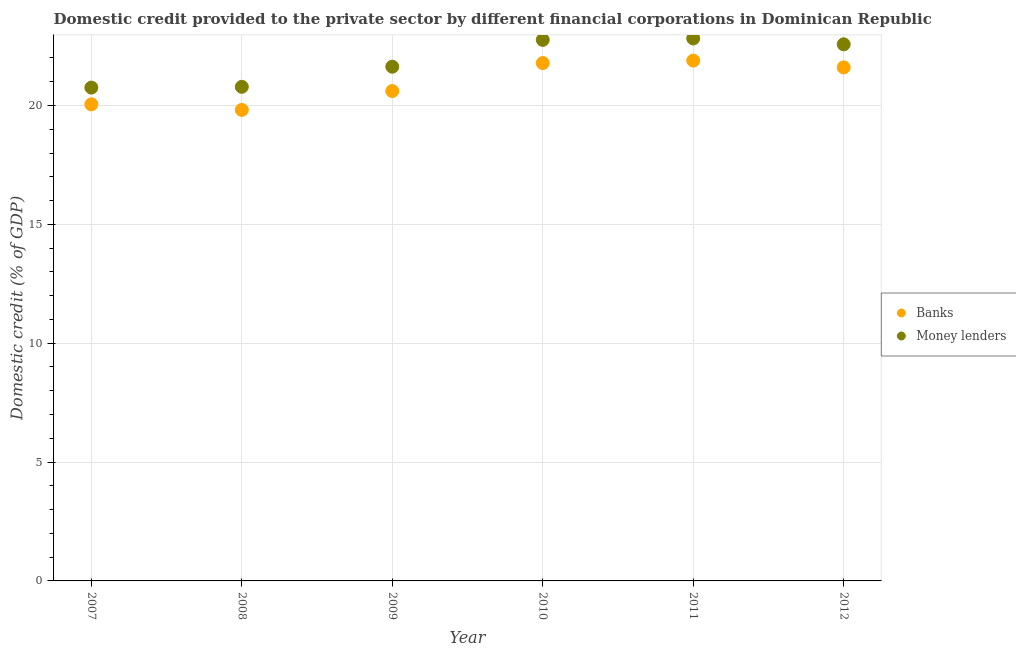What is the domestic credit provided by banks in 2008?
Offer a very short reply. 19.81. Across all years, what is the maximum domestic credit provided by banks?
Provide a succinct answer. 21.89. Across all years, what is the minimum domestic credit provided by money lenders?
Give a very brief answer. 20.75. In which year was the domestic credit provided by money lenders minimum?
Keep it short and to the point. 2007. What is the total domestic credit provided by banks in the graph?
Give a very brief answer. 125.74. What is the difference between the domestic credit provided by banks in 2008 and that in 2009?
Your answer should be compact. -0.79. What is the difference between the domestic credit provided by banks in 2011 and the domestic credit provided by money lenders in 2012?
Your answer should be very brief. -0.69. What is the average domestic credit provided by banks per year?
Your response must be concise. 20.96. In the year 2008, what is the difference between the domestic credit provided by banks and domestic credit provided by money lenders?
Your answer should be compact. -0.97. In how many years, is the domestic credit provided by money lenders greater than 17 %?
Ensure brevity in your answer.  6. What is the ratio of the domestic credit provided by banks in 2007 to that in 2010?
Ensure brevity in your answer.  0.92. Is the difference between the domestic credit provided by banks in 2008 and 2010 greater than the difference between the domestic credit provided by money lenders in 2008 and 2010?
Offer a very short reply. Yes. What is the difference between the highest and the second highest domestic credit provided by banks?
Ensure brevity in your answer.  0.1. What is the difference between the highest and the lowest domestic credit provided by banks?
Offer a very short reply. 2.07. Is the domestic credit provided by banks strictly greater than the domestic credit provided by money lenders over the years?
Offer a very short reply. No. How many dotlines are there?
Your answer should be very brief. 2. How many years are there in the graph?
Ensure brevity in your answer.  6. Does the graph contain any zero values?
Your answer should be very brief. No. How many legend labels are there?
Provide a short and direct response. 2. How are the legend labels stacked?
Your answer should be very brief. Vertical. What is the title of the graph?
Your answer should be compact. Domestic credit provided to the private sector by different financial corporations in Dominican Republic. What is the label or title of the X-axis?
Ensure brevity in your answer.  Year. What is the label or title of the Y-axis?
Your response must be concise. Domestic credit (% of GDP). What is the Domestic credit (% of GDP) in Banks in 2007?
Ensure brevity in your answer.  20.05. What is the Domestic credit (% of GDP) in Money lenders in 2007?
Give a very brief answer. 20.75. What is the Domestic credit (% of GDP) of Banks in 2008?
Offer a terse response. 19.81. What is the Domestic credit (% of GDP) in Money lenders in 2008?
Your response must be concise. 20.79. What is the Domestic credit (% of GDP) of Banks in 2009?
Provide a succinct answer. 20.61. What is the Domestic credit (% of GDP) in Money lenders in 2009?
Your answer should be very brief. 21.63. What is the Domestic credit (% of GDP) of Banks in 2010?
Provide a short and direct response. 21.79. What is the Domestic credit (% of GDP) in Money lenders in 2010?
Ensure brevity in your answer.  22.76. What is the Domestic credit (% of GDP) of Banks in 2011?
Make the answer very short. 21.89. What is the Domestic credit (% of GDP) in Money lenders in 2011?
Provide a short and direct response. 22.82. What is the Domestic credit (% of GDP) in Banks in 2012?
Provide a succinct answer. 21.6. What is the Domestic credit (% of GDP) of Money lenders in 2012?
Offer a very short reply. 22.57. Across all years, what is the maximum Domestic credit (% of GDP) in Banks?
Keep it short and to the point. 21.89. Across all years, what is the maximum Domestic credit (% of GDP) of Money lenders?
Offer a terse response. 22.82. Across all years, what is the minimum Domestic credit (% of GDP) of Banks?
Keep it short and to the point. 19.81. Across all years, what is the minimum Domestic credit (% of GDP) in Money lenders?
Make the answer very short. 20.75. What is the total Domestic credit (% of GDP) of Banks in the graph?
Provide a short and direct response. 125.74. What is the total Domestic credit (% of GDP) in Money lenders in the graph?
Provide a succinct answer. 131.32. What is the difference between the Domestic credit (% of GDP) in Banks in 2007 and that in 2008?
Your response must be concise. 0.23. What is the difference between the Domestic credit (% of GDP) in Money lenders in 2007 and that in 2008?
Your response must be concise. -0.03. What is the difference between the Domestic credit (% of GDP) in Banks in 2007 and that in 2009?
Offer a terse response. -0.56. What is the difference between the Domestic credit (% of GDP) in Money lenders in 2007 and that in 2009?
Provide a short and direct response. -0.88. What is the difference between the Domestic credit (% of GDP) of Banks in 2007 and that in 2010?
Provide a short and direct response. -1.74. What is the difference between the Domestic credit (% of GDP) of Money lenders in 2007 and that in 2010?
Your answer should be very brief. -2.01. What is the difference between the Domestic credit (% of GDP) in Banks in 2007 and that in 2011?
Provide a succinct answer. -1.84. What is the difference between the Domestic credit (% of GDP) of Money lenders in 2007 and that in 2011?
Your answer should be compact. -2.07. What is the difference between the Domestic credit (% of GDP) in Banks in 2007 and that in 2012?
Offer a terse response. -1.55. What is the difference between the Domestic credit (% of GDP) in Money lenders in 2007 and that in 2012?
Offer a very short reply. -1.82. What is the difference between the Domestic credit (% of GDP) in Banks in 2008 and that in 2009?
Your answer should be compact. -0.79. What is the difference between the Domestic credit (% of GDP) in Money lenders in 2008 and that in 2009?
Keep it short and to the point. -0.85. What is the difference between the Domestic credit (% of GDP) in Banks in 2008 and that in 2010?
Offer a very short reply. -1.97. What is the difference between the Domestic credit (% of GDP) of Money lenders in 2008 and that in 2010?
Keep it short and to the point. -1.97. What is the difference between the Domestic credit (% of GDP) in Banks in 2008 and that in 2011?
Provide a short and direct response. -2.07. What is the difference between the Domestic credit (% of GDP) of Money lenders in 2008 and that in 2011?
Offer a very short reply. -2.04. What is the difference between the Domestic credit (% of GDP) of Banks in 2008 and that in 2012?
Your answer should be very brief. -1.79. What is the difference between the Domestic credit (% of GDP) in Money lenders in 2008 and that in 2012?
Ensure brevity in your answer.  -1.79. What is the difference between the Domestic credit (% of GDP) in Banks in 2009 and that in 2010?
Give a very brief answer. -1.18. What is the difference between the Domestic credit (% of GDP) in Money lenders in 2009 and that in 2010?
Make the answer very short. -1.13. What is the difference between the Domestic credit (% of GDP) in Banks in 2009 and that in 2011?
Provide a succinct answer. -1.28. What is the difference between the Domestic credit (% of GDP) of Money lenders in 2009 and that in 2011?
Your answer should be compact. -1.19. What is the difference between the Domestic credit (% of GDP) in Banks in 2009 and that in 2012?
Ensure brevity in your answer.  -1. What is the difference between the Domestic credit (% of GDP) of Money lenders in 2009 and that in 2012?
Give a very brief answer. -0.94. What is the difference between the Domestic credit (% of GDP) of Banks in 2010 and that in 2011?
Keep it short and to the point. -0.1. What is the difference between the Domestic credit (% of GDP) in Money lenders in 2010 and that in 2011?
Provide a short and direct response. -0.06. What is the difference between the Domestic credit (% of GDP) in Banks in 2010 and that in 2012?
Keep it short and to the point. 0.18. What is the difference between the Domestic credit (% of GDP) of Money lenders in 2010 and that in 2012?
Offer a terse response. 0.19. What is the difference between the Domestic credit (% of GDP) in Banks in 2011 and that in 2012?
Your answer should be very brief. 0.29. What is the difference between the Domestic credit (% of GDP) in Money lenders in 2011 and that in 2012?
Give a very brief answer. 0.25. What is the difference between the Domestic credit (% of GDP) in Banks in 2007 and the Domestic credit (% of GDP) in Money lenders in 2008?
Offer a terse response. -0.74. What is the difference between the Domestic credit (% of GDP) of Banks in 2007 and the Domestic credit (% of GDP) of Money lenders in 2009?
Ensure brevity in your answer.  -1.58. What is the difference between the Domestic credit (% of GDP) of Banks in 2007 and the Domestic credit (% of GDP) of Money lenders in 2010?
Your answer should be very brief. -2.71. What is the difference between the Domestic credit (% of GDP) of Banks in 2007 and the Domestic credit (% of GDP) of Money lenders in 2011?
Offer a very short reply. -2.77. What is the difference between the Domestic credit (% of GDP) of Banks in 2007 and the Domestic credit (% of GDP) of Money lenders in 2012?
Provide a short and direct response. -2.53. What is the difference between the Domestic credit (% of GDP) in Banks in 2008 and the Domestic credit (% of GDP) in Money lenders in 2009?
Your answer should be compact. -1.82. What is the difference between the Domestic credit (% of GDP) in Banks in 2008 and the Domestic credit (% of GDP) in Money lenders in 2010?
Give a very brief answer. -2.95. What is the difference between the Domestic credit (% of GDP) of Banks in 2008 and the Domestic credit (% of GDP) of Money lenders in 2011?
Your answer should be very brief. -3.01. What is the difference between the Domestic credit (% of GDP) of Banks in 2008 and the Domestic credit (% of GDP) of Money lenders in 2012?
Ensure brevity in your answer.  -2.76. What is the difference between the Domestic credit (% of GDP) in Banks in 2009 and the Domestic credit (% of GDP) in Money lenders in 2010?
Keep it short and to the point. -2.15. What is the difference between the Domestic credit (% of GDP) in Banks in 2009 and the Domestic credit (% of GDP) in Money lenders in 2011?
Your answer should be compact. -2.21. What is the difference between the Domestic credit (% of GDP) in Banks in 2009 and the Domestic credit (% of GDP) in Money lenders in 2012?
Your answer should be very brief. -1.97. What is the difference between the Domestic credit (% of GDP) of Banks in 2010 and the Domestic credit (% of GDP) of Money lenders in 2011?
Offer a very short reply. -1.04. What is the difference between the Domestic credit (% of GDP) of Banks in 2010 and the Domestic credit (% of GDP) of Money lenders in 2012?
Your answer should be very brief. -0.79. What is the difference between the Domestic credit (% of GDP) of Banks in 2011 and the Domestic credit (% of GDP) of Money lenders in 2012?
Provide a succinct answer. -0.69. What is the average Domestic credit (% of GDP) of Banks per year?
Your answer should be compact. 20.96. What is the average Domestic credit (% of GDP) of Money lenders per year?
Your response must be concise. 21.89. In the year 2007, what is the difference between the Domestic credit (% of GDP) in Banks and Domestic credit (% of GDP) in Money lenders?
Give a very brief answer. -0.7. In the year 2008, what is the difference between the Domestic credit (% of GDP) of Banks and Domestic credit (% of GDP) of Money lenders?
Give a very brief answer. -0.97. In the year 2009, what is the difference between the Domestic credit (% of GDP) of Banks and Domestic credit (% of GDP) of Money lenders?
Provide a short and direct response. -1.02. In the year 2010, what is the difference between the Domestic credit (% of GDP) of Banks and Domestic credit (% of GDP) of Money lenders?
Offer a very short reply. -0.97. In the year 2011, what is the difference between the Domestic credit (% of GDP) in Banks and Domestic credit (% of GDP) in Money lenders?
Offer a terse response. -0.93. In the year 2012, what is the difference between the Domestic credit (% of GDP) of Banks and Domestic credit (% of GDP) of Money lenders?
Your response must be concise. -0.97. What is the ratio of the Domestic credit (% of GDP) of Banks in 2007 to that in 2008?
Your answer should be compact. 1.01. What is the ratio of the Domestic credit (% of GDP) in Money lenders in 2007 to that in 2008?
Give a very brief answer. 1. What is the ratio of the Domestic credit (% of GDP) of Banks in 2007 to that in 2009?
Make the answer very short. 0.97. What is the ratio of the Domestic credit (% of GDP) of Money lenders in 2007 to that in 2009?
Provide a short and direct response. 0.96. What is the ratio of the Domestic credit (% of GDP) in Banks in 2007 to that in 2010?
Give a very brief answer. 0.92. What is the ratio of the Domestic credit (% of GDP) of Money lenders in 2007 to that in 2010?
Ensure brevity in your answer.  0.91. What is the ratio of the Domestic credit (% of GDP) in Banks in 2007 to that in 2011?
Ensure brevity in your answer.  0.92. What is the ratio of the Domestic credit (% of GDP) in Money lenders in 2007 to that in 2011?
Ensure brevity in your answer.  0.91. What is the ratio of the Domestic credit (% of GDP) in Banks in 2007 to that in 2012?
Offer a very short reply. 0.93. What is the ratio of the Domestic credit (% of GDP) of Money lenders in 2007 to that in 2012?
Your answer should be compact. 0.92. What is the ratio of the Domestic credit (% of GDP) of Banks in 2008 to that in 2009?
Make the answer very short. 0.96. What is the ratio of the Domestic credit (% of GDP) of Money lenders in 2008 to that in 2009?
Give a very brief answer. 0.96. What is the ratio of the Domestic credit (% of GDP) in Banks in 2008 to that in 2010?
Your answer should be very brief. 0.91. What is the ratio of the Domestic credit (% of GDP) in Money lenders in 2008 to that in 2010?
Your response must be concise. 0.91. What is the ratio of the Domestic credit (% of GDP) in Banks in 2008 to that in 2011?
Provide a short and direct response. 0.91. What is the ratio of the Domestic credit (% of GDP) of Money lenders in 2008 to that in 2011?
Keep it short and to the point. 0.91. What is the ratio of the Domestic credit (% of GDP) of Banks in 2008 to that in 2012?
Ensure brevity in your answer.  0.92. What is the ratio of the Domestic credit (% of GDP) in Money lenders in 2008 to that in 2012?
Keep it short and to the point. 0.92. What is the ratio of the Domestic credit (% of GDP) in Banks in 2009 to that in 2010?
Your answer should be compact. 0.95. What is the ratio of the Domestic credit (% of GDP) in Money lenders in 2009 to that in 2010?
Your answer should be compact. 0.95. What is the ratio of the Domestic credit (% of GDP) in Banks in 2009 to that in 2011?
Provide a succinct answer. 0.94. What is the ratio of the Domestic credit (% of GDP) of Money lenders in 2009 to that in 2011?
Offer a very short reply. 0.95. What is the ratio of the Domestic credit (% of GDP) of Banks in 2009 to that in 2012?
Provide a short and direct response. 0.95. What is the ratio of the Domestic credit (% of GDP) in Money lenders in 2009 to that in 2012?
Provide a succinct answer. 0.96. What is the ratio of the Domestic credit (% of GDP) of Banks in 2010 to that in 2012?
Your answer should be compact. 1.01. What is the ratio of the Domestic credit (% of GDP) of Money lenders in 2010 to that in 2012?
Provide a succinct answer. 1.01. What is the ratio of the Domestic credit (% of GDP) of Banks in 2011 to that in 2012?
Provide a succinct answer. 1.01. What is the ratio of the Domestic credit (% of GDP) of Money lenders in 2011 to that in 2012?
Ensure brevity in your answer.  1.01. What is the difference between the highest and the second highest Domestic credit (% of GDP) of Banks?
Ensure brevity in your answer.  0.1. What is the difference between the highest and the second highest Domestic credit (% of GDP) of Money lenders?
Provide a short and direct response. 0.06. What is the difference between the highest and the lowest Domestic credit (% of GDP) of Banks?
Offer a terse response. 2.07. What is the difference between the highest and the lowest Domestic credit (% of GDP) in Money lenders?
Provide a short and direct response. 2.07. 